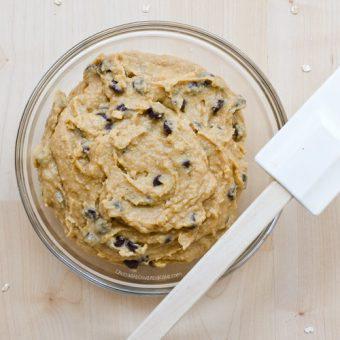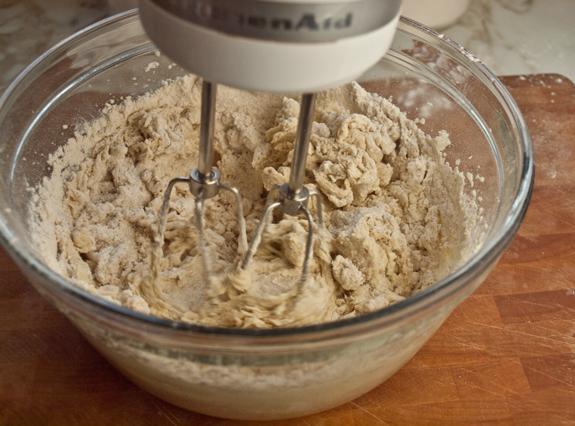The first image is the image on the left, the second image is the image on the right. Considering the images on both sides, is "Each image features a bowl of ingredients, with a utensil in the bowl and its one handle sticking out." valid? Answer yes or no. No. The first image is the image on the left, the second image is the image on the right. Evaluate the accuracy of this statement regarding the images: "One of the images does not contain a handheld utensil.". Is it true? Answer yes or no. Yes. 